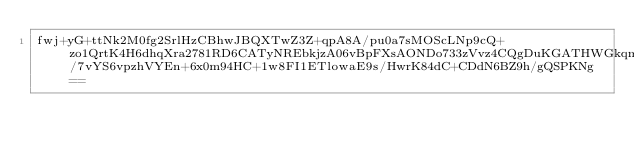<code> <loc_0><loc_0><loc_500><loc_500><_SML_>fwj+yG+ttNk2M0fg2SrlHzCBhwJBQXTwZ3Z+qpA8A/pu0a7sMOScLNp9cQ+zo1QrtK4H6dhqXra2781RD6CATyNREbkjzA06vBpFXsAONDo733zVvz4CQgDuKGATHWGkqmDUYiti4BsG/7vYS6vpzhVYEn+6x0m94HC+1w8FI1ETlowaE9s/HwrK84dC+CDdN6BZ9h/gQSPKNg==</code> 